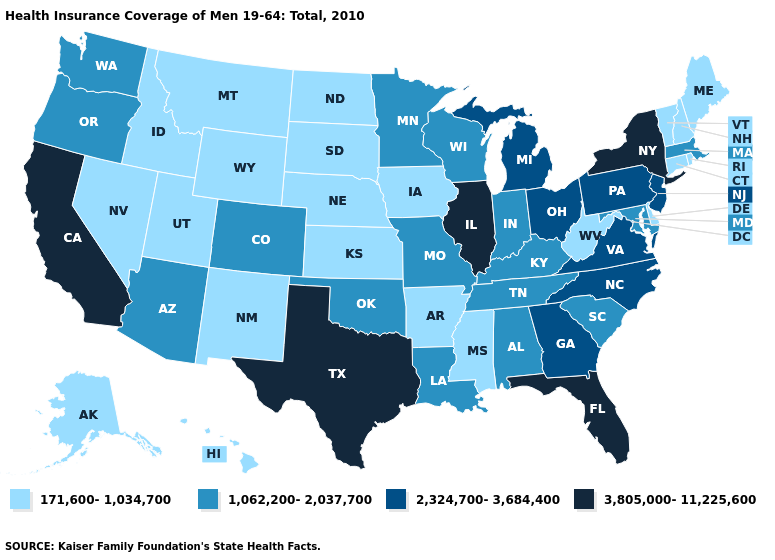Among the states that border Colorado , does Nebraska have the lowest value?
Short answer required. Yes. Which states have the highest value in the USA?
Write a very short answer. California, Florida, Illinois, New York, Texas. Does New York have the highest value in the Northeast?
Answer briefly. Yes. Which states hav the highest value in the South?
Keep it brief. Florida, Texas. Does Nevada have the lowest value in the West?
Concise answer only. Yes. Does California have the highest value in the USA?
Answer briefly. Yes. Name the states that have a value in the range 1,062,200-2,037,700?
Quick response, please. Alabama, Arizona, Colorado, Indiana, Kentucky, Louisiana, Maryland, Massachusetts, Minnesota, Missouri, Oklahoma, Oregon, South Carolina, Tennessee, Washington, Wisconsin. Name the states that have a value in the range 1,062,200-2,037,700?
Quick response, please. Alabama, Arizona, Colorado, Indiana, Kentucky, Louisiana, Maryland, Massachusetts, Minnesota, Missouri, Oklahoma, Oregon, South Carolina, Tennessee, Washington, Wisconsin. Name the states that have a value in the range 171,600-1,034,700?
Keep it brief. Alaska, Arkansas, Connecticut, Delaware, Hawaii, Idaho, Iowa, Kansas, Maine, Mississippi, Montana, Nebraska, Nevada, New Hampshire, New Mexico, North Dakota, Rhode Island, South Dakota, Utah, Vermont, West Virginia, Wyoming. What is the value of Montana?
Quick response, please. 171,600-1,034,700. Does Arkansas have the highest value in the USA?
Short answer required. No. Does the map have missing data?
Keep it brief. No. Which states have the lowest value in the MidWest?
Write a very short answer. Iowa, Kansas, Nebraska, North Dakota, South Dakota. Name the states that have a value in the range 2,324,700-3,684,400?
Quick response, please. Georgia, Michigan, New Jersey, North Carolina, Ohio, Pennsylvania, Virginia. Does Iowa have a higher value than Minnesota?
Keep it brief. No. 